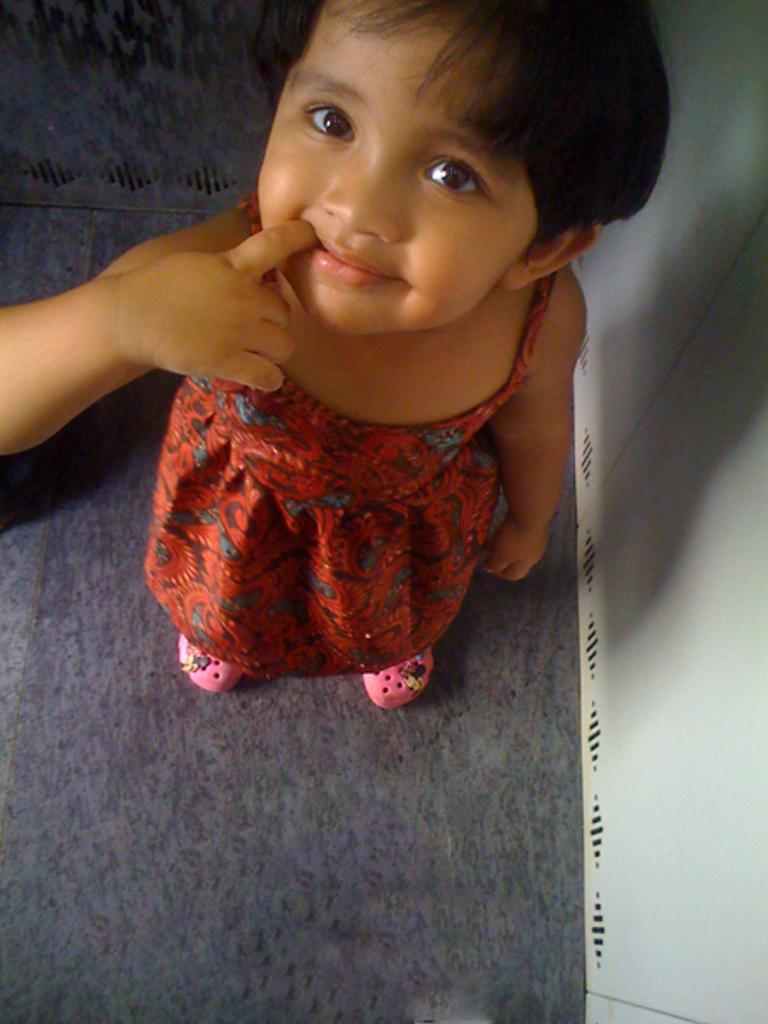Who is the main subject in the image? There is a girl in the image. What is the girl wearing on her feet? The girl is wearing pink shoes. Where is the girl standing in the image? The girl is standing near a white object that resembles a wall. What is on the floor in the image? There is a carpet on the floor in the image. Can you tell me how many ovens are visible in the image? There are no ovens present in the image. 